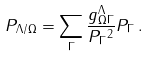<formula> <loc_0><loc_0><loc_500><loc_500>P _ { \Lambda / \Omega } = \sum _ { \Gamma } \frac { g ^ { \Lambda } _ { \Omega \Gamma } } { \| P _ { \Gamma } \| ^ { 2 } } P _ { \Gamma } \, .</formula> 